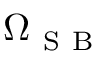Convert formula to latex. <formula><loc_0><loc_0><loc_500><loc_500>\Omega _ { S B }</formula> 